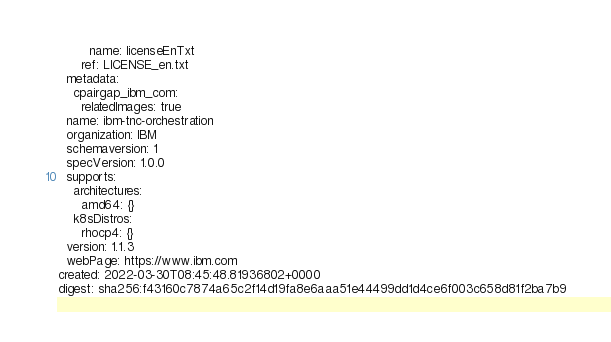Convert code to text. <code><loc_0><loc_0><loc_500><loc_500><_YAML_>        name: licenseEnTxt
      ref: LICENSE_en.txt
  metadata:
    cpairgap_ibm_com:
      relatedImages: true
  name: ibm-tnc-orchestration
  organization: IBM
  schemaversion: 1
  specVersion: 1.0.0
  supports:
    architectures:
      amd64: {}
    k8sDistros:
      rhocp4: {}
  version: 1.1.3
  webPage: https://www.ibm.com
created: 2022-03-30T08:45:48.81936802+0000
digest: sha256:f43160c7874a65c2f14d19fa8e6aaa51e44499dd1d4ce6f003c658d81f2ba7b9
</code> 